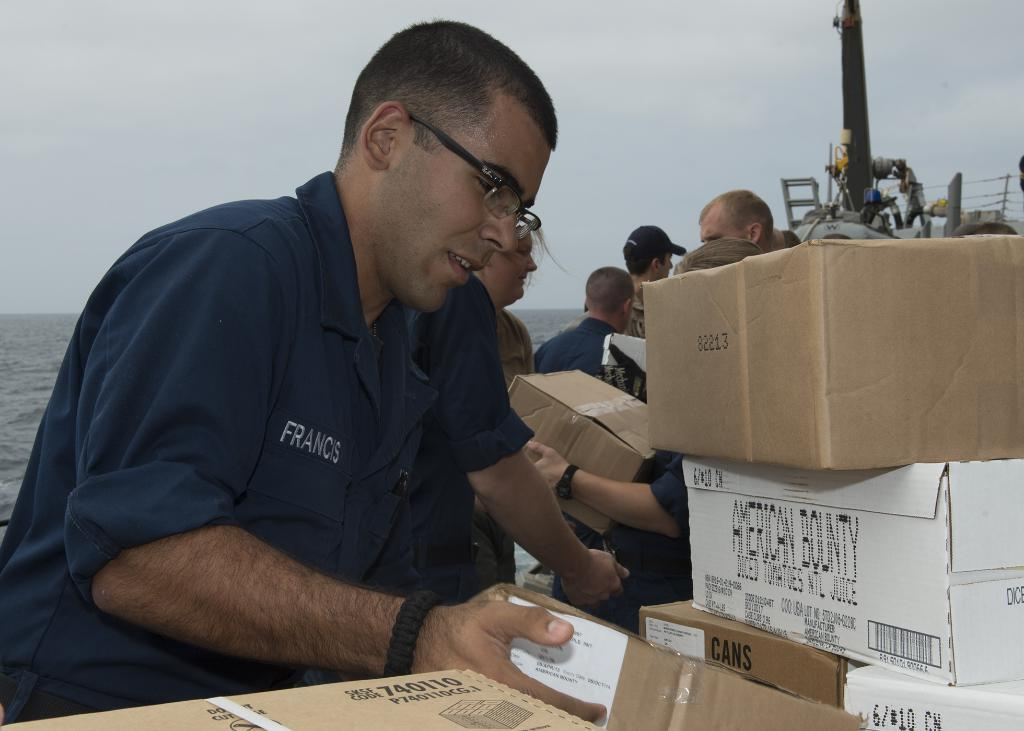How many people are in the image? There is a group of persons in the image. What are some of the persons holding? Some of the persons are holding wooden boxes. Where are additional wooden boxes located in the image? There are wooden boxes in the right corner of the image. What type of cork can be seen on the wooden boxes in the image? There is no cork visible on the wooden boxes in the image. How many mittens are being worn by the persons in the image? There is no mention of mittens in the image, so it cannot be determined how many are being worn. 